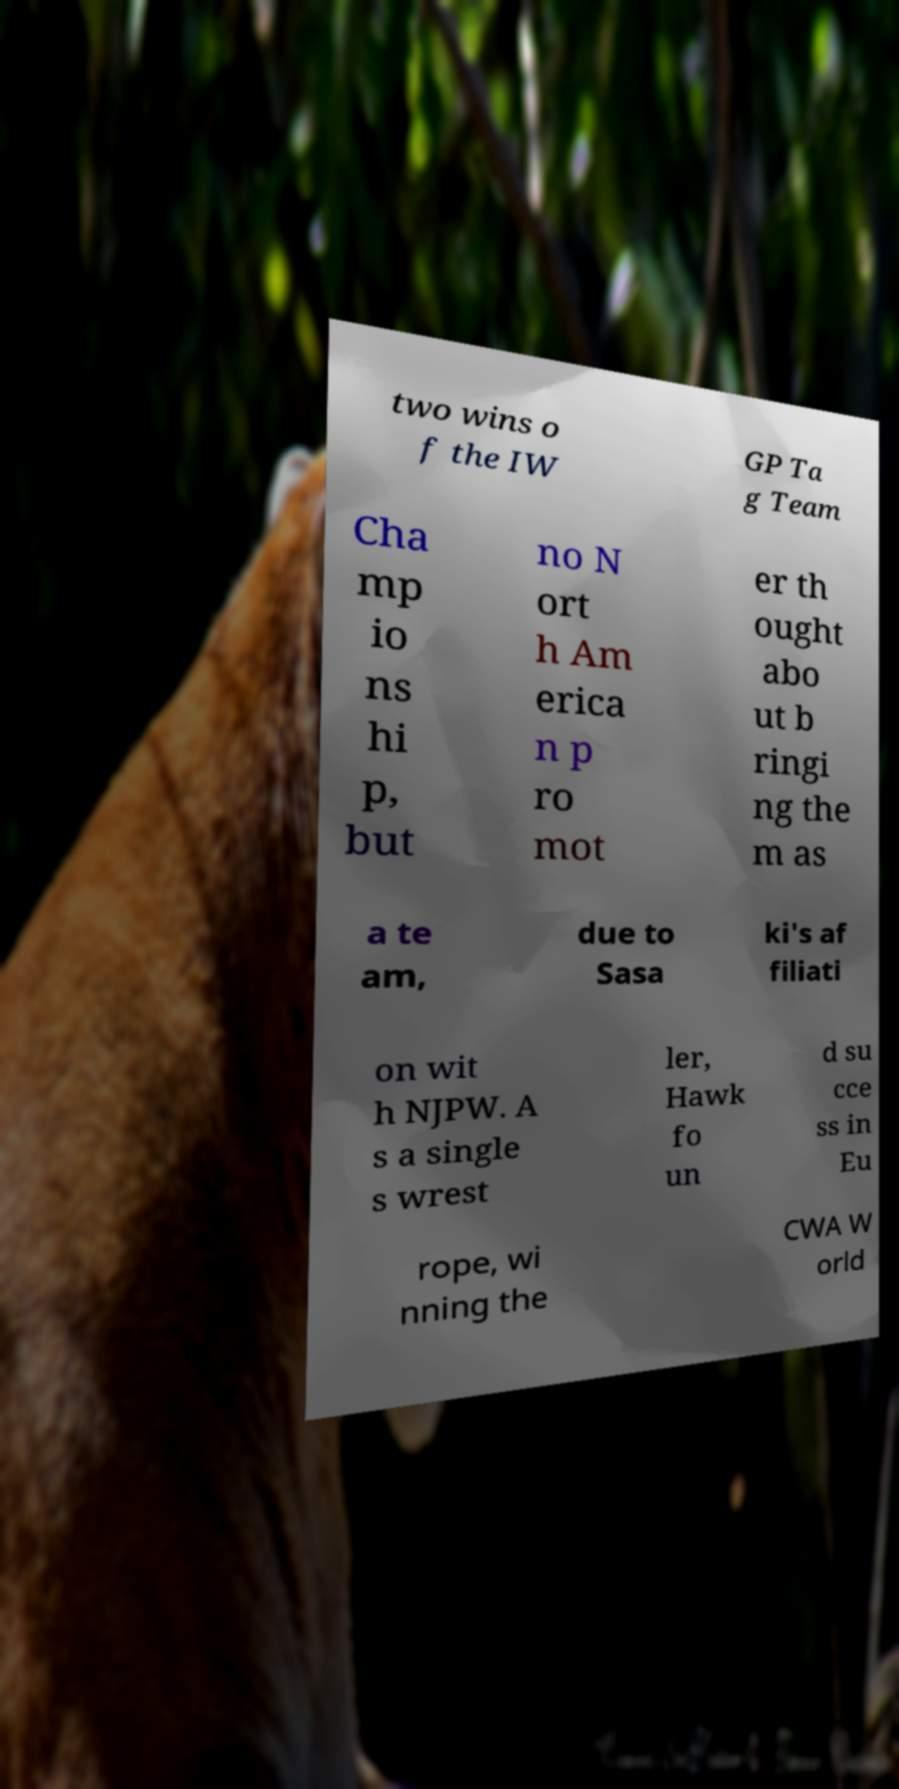I need the written content from this picture converted into text. Can you do that? two wins o f the IW GP Ta g Team Cha mp io ns hi p, but no N ort h Am erica n p ro mot er th ought abo ut b ringi ng the m as a te am, due to Sasa ki's af filiati on wit h NJPW. A s a single s wrest ler, Hawk fo un d su cce ss in Eu rope, wi nning the CWA W orld 